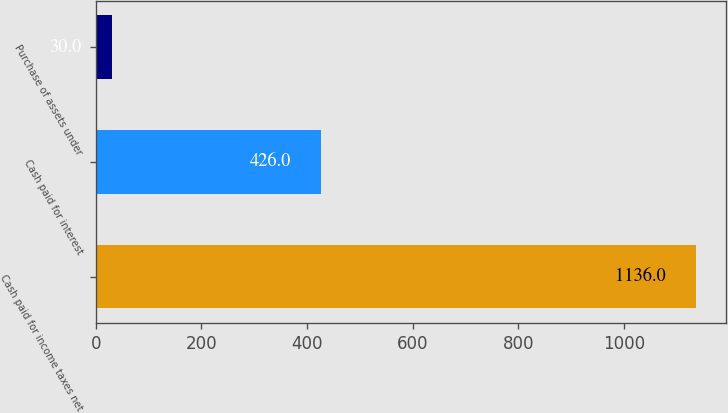Convert chart to OTSL. <chart><loc_0><loc_0><loc_500><loc_500><bar_chart><fcel>Cash paid for income taxes net<fcel>Cash paid for interest<fcel>Purchase of assets under<nl><fcel>1136<fcel>426<fcel>30<nl></chart> 